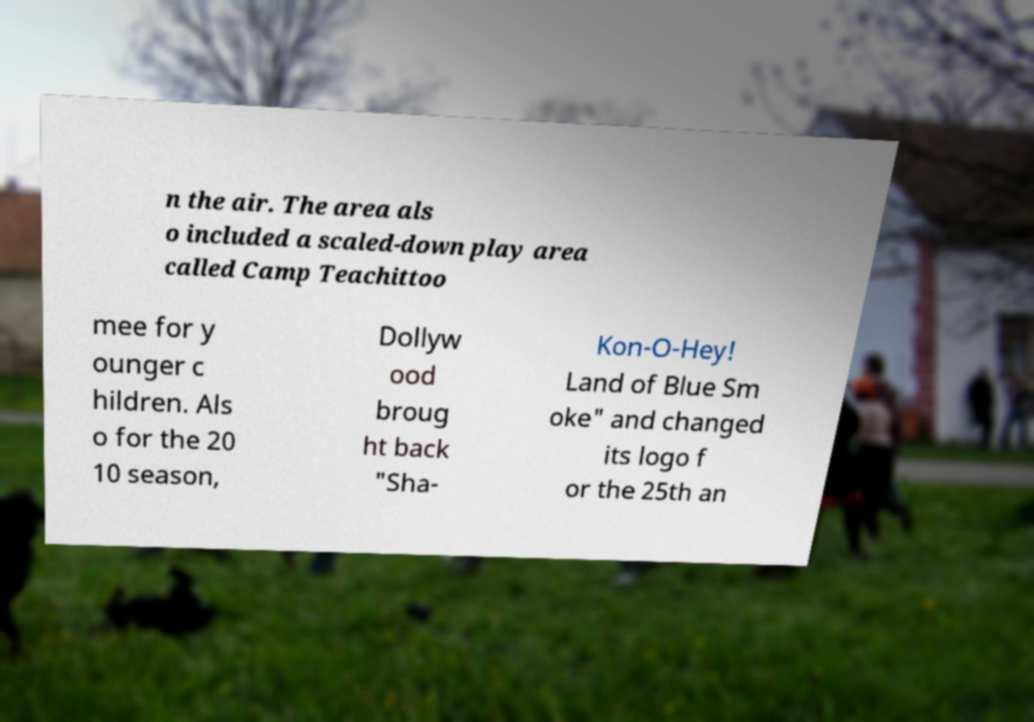There's text embedded in this image that I need extracted. Can you transcribe it verbatim? n the air. The area als o included a scaled-down play area called Camp Teachittoo mee for y ounger c hildren. Als o for the 20 10 season, Dollyw ood broug ht back "Sha- Kon-O-Hey! Land of Blue Sm oke" and changed its logo f or the 25th an 